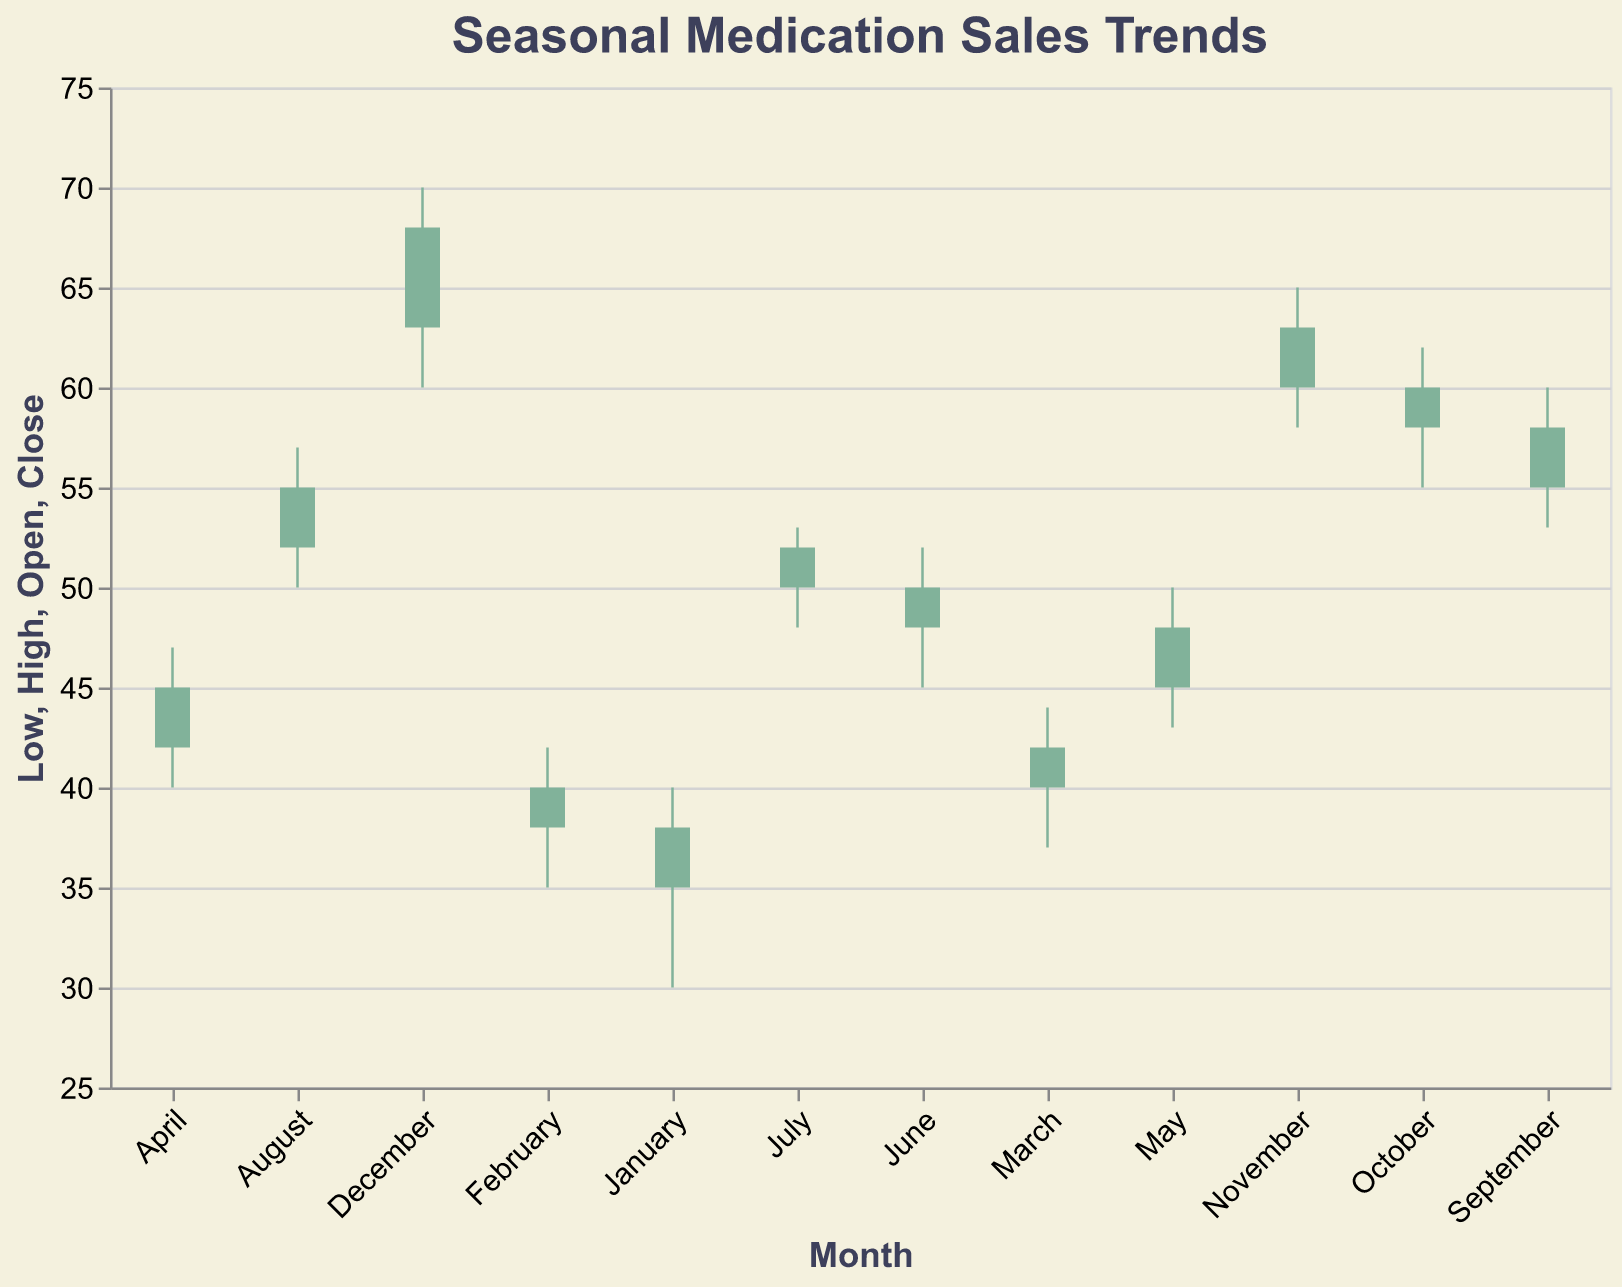What is the title of the plot? The title is displayed at the top of the plot. It visually reads "Seasonal Medication Sales Trends".
Answer: Seasonal Medication Sales Trends Which month has the highest closing value? From the candlestick plot, December has the highest closing value shown at 68.
Answer: December How does October's closing value compare to November's closing value? October's closing value is 60, while November's closing value is 63. Comparing these values shows November's closing value is 3 higher than October's.
Answer: November's is higher Which month shows the largest range between the high and low values? The range can be calculated by subtracting the low value from the high value for each month. December has the highest range from 60 to 70, which is a range of 10.
Answer: December In which month did the closing value exceed the opening value by the greatest amount? By computing the difference for each month (Close - Open), we find August (55 - 52 = 3), September (58 - 55 = 3), November (63 - 60 = 3), and December (68 - 63 = 5). December exceeds the opening value by the greatest amount of 5.
Answer: December What is the lowest opening value in the first quarter (January to March)? January has the lowest opening value of 35 among January (35), February (38), and March (40).
Answer: January Which month experienced the smallest difference between the opening and closing values? By calculating the difference for each month (Close - Open), we find July has the smallest difference where Open (50) and Close (52) difference equals 2.
Answer: July Did any month's opening value equal its closing value? By checking each month's Open and Close values, there is no month where the opening value equals the closing value.
Answer: No How does the high value in September compare with the high value in May? September's high (60) and May's high (50) show that September's high value is higher by 10 units.
Answer: September is higher How many months had closing values below 50? By examining each month's closing value, we have January (38), February (40), March (42), April (45), May (48), and June (50). Five months had closing values below 50.
Answer: 5 